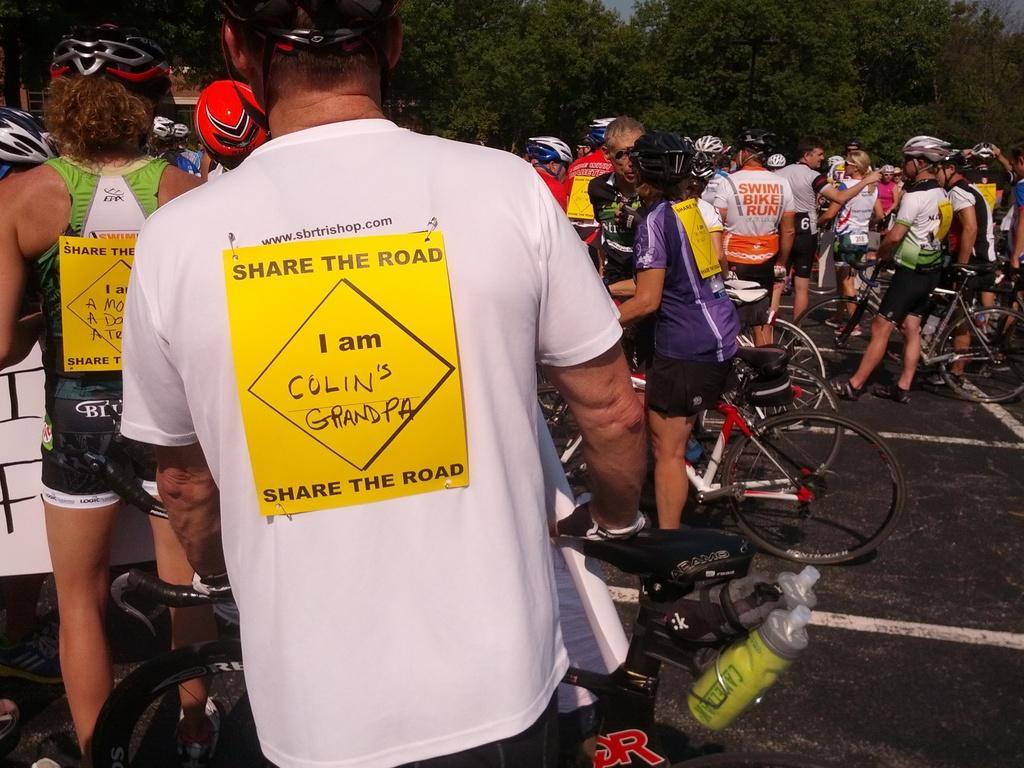Describe this image in one or two sentences. In this image, we can see some persons and bicycles. There are trees at the top of the image. 